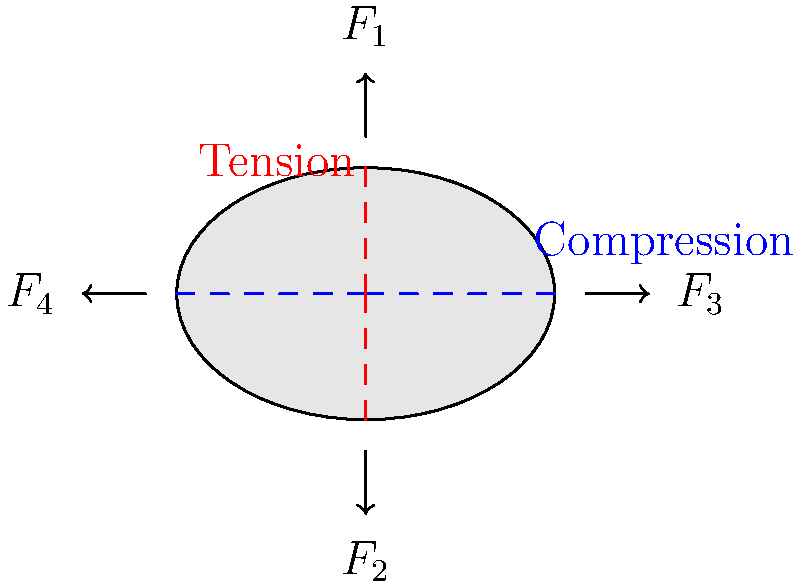As a biomechanics expert focused on your successful career, analyze the stress distribution in the bone cross-section shown above. If $F_1 = F_2 = 100N$ and $F_3 = F_4 = 50N$, calculate the maximum normal stress $\sigma_{max}$ in the bone. Assume the bone has a cross-sectional area $A = 15 cm^2$ and a moment of inertia $I = 5 cm^4$ about both principal axes. Let's approach this step-by-step:

1) First, we need to identify the types of stress present:
   - Axial stress due to $F_1$ and $F_2$
   - Bending stress due to $F_3$ and $F_4$

2) Calculate the axial stress:
   $\sigma_{axial} = \frac{F}{A} = \frac{F_1 - F_2}{A} = \frac{100N - 100N}{15 cm^2} = 0$

3) Calculate the bending moment:
   $M = F_3 \times d = F_4 \times d = 50N \times 3cm = 150 N\cdot cm$

4) Calculate the bending stress:
   $\sigma_{bending} = \frac{Mc}{I}$, where $c$ is the distance from the neutral axis to the outer fiber (1.5 cm in this case)
   $\sigma_{bending} = \frac{150 N\cdot cm \times 1.5 cm}{5 cm^4} = 45 N/cm^2 = 4.5 MPa$

5) The maximum normal stress occurs where the bending stress is maximum:
   $\sigma_{max} = \sigma_{axial} + \sigma_{bending} = 0 + 4.5 MPa = 4.5 MPa$

Therefore, the maximum normal stress in the bone is 4.5 MPa.
Answer: 4.5 MPa 